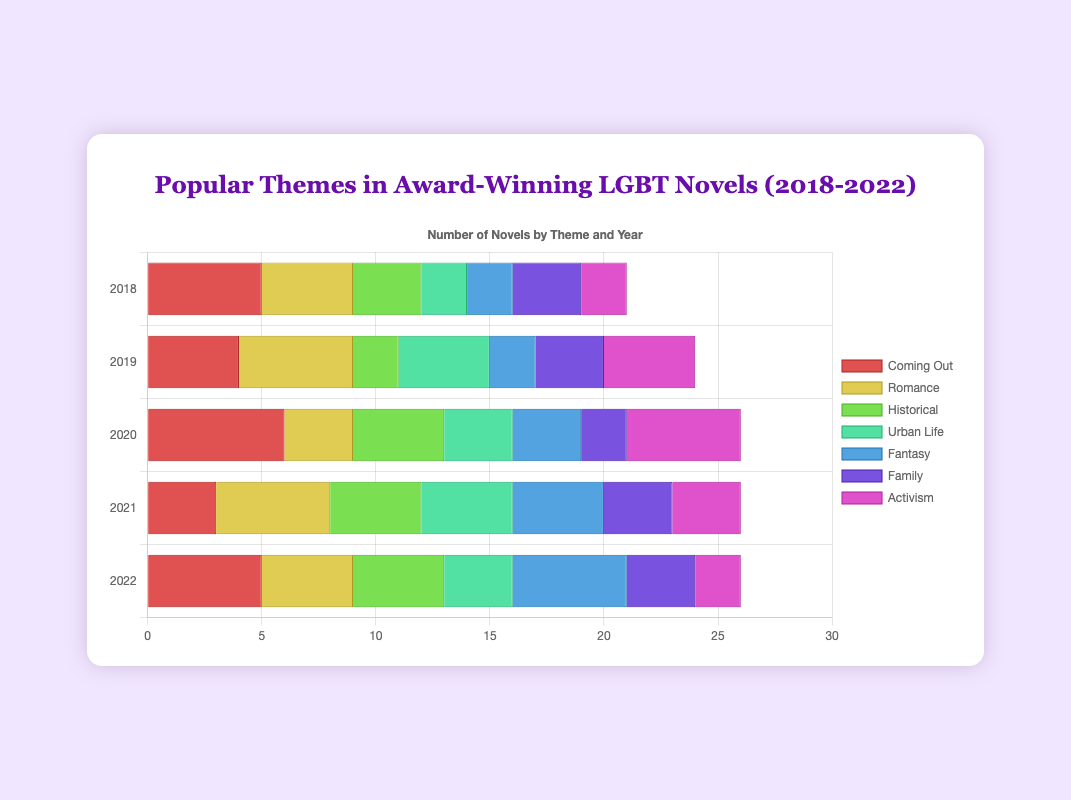What theme was most consistent in numbers for 2021 and 2022? Compare the numbers of each theme from 2021 and 2022 and find the one with the least fluctuation. "Romance" had 5 novels in both years, showing consistency.
Answer: Romance How many novels featured the theme "Historical" in total across all years? Sum the novels featuring "Historical" across all years: 3 (2018) + 2 (2019) + 4 (2020) + 4 (2021) + 4 (2022). The total is 17 novels.
Answer: 17 Which year saw the highest number of "Activism" themed novels? Review each year's data to identify the peak for "Activism": 2018 (2), 2019 (4), 2020 (5), 2021 (3), 2022 (2). 2020 had the most with 5 novels.
Answer: 2020 How did the theme "Urban Life" change from 2018 to 2019? Compare "Urban Life" numbers between the two years: 2 (2018) vs 4 (2019). The increase was from 2 to 4 novels.
Answer: Increased What is the average number of novels per year featuring "Fantasy" from 2018 to 2022? Sum the "Fantasy" numbers across all years, then divide by the number of years: (2 + 2 + 3 + 4 + 5) / 5 = 3.2.
Answer: 3.2 Which two themes collectively had the most novels in 2020? Identify two themes with the highest combined totals in 2020. "Coming Out" (6) and "Activism" (5) total 11 novels.
Answer: Coming Out and Activism For which theme did the number of novels triple from 2019 to 2020? Compare numbers for each theme from 2019 to 2020 to find a tripling. "Activism" grew from 4 in 2019 to 15 in 2020, which triples.
Answer: Activism 